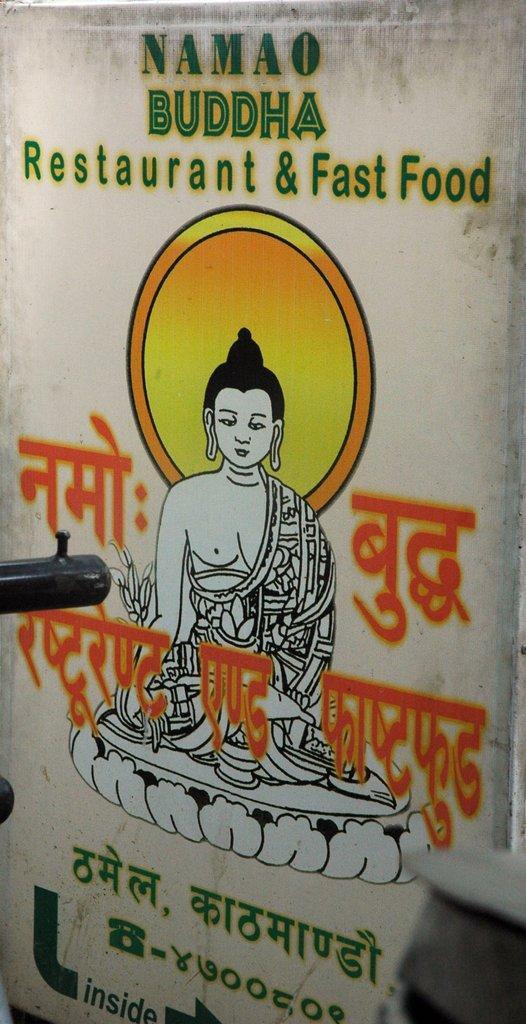Could you give a brief overview of what you see in this image? In the picture we can see a poster of the advertisement of restaurant and fast food and a painting of lord Buddha on it. 